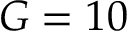<formula> <loc_0><loc_0><loc_500><loc_500>G = 1 0</formula> 